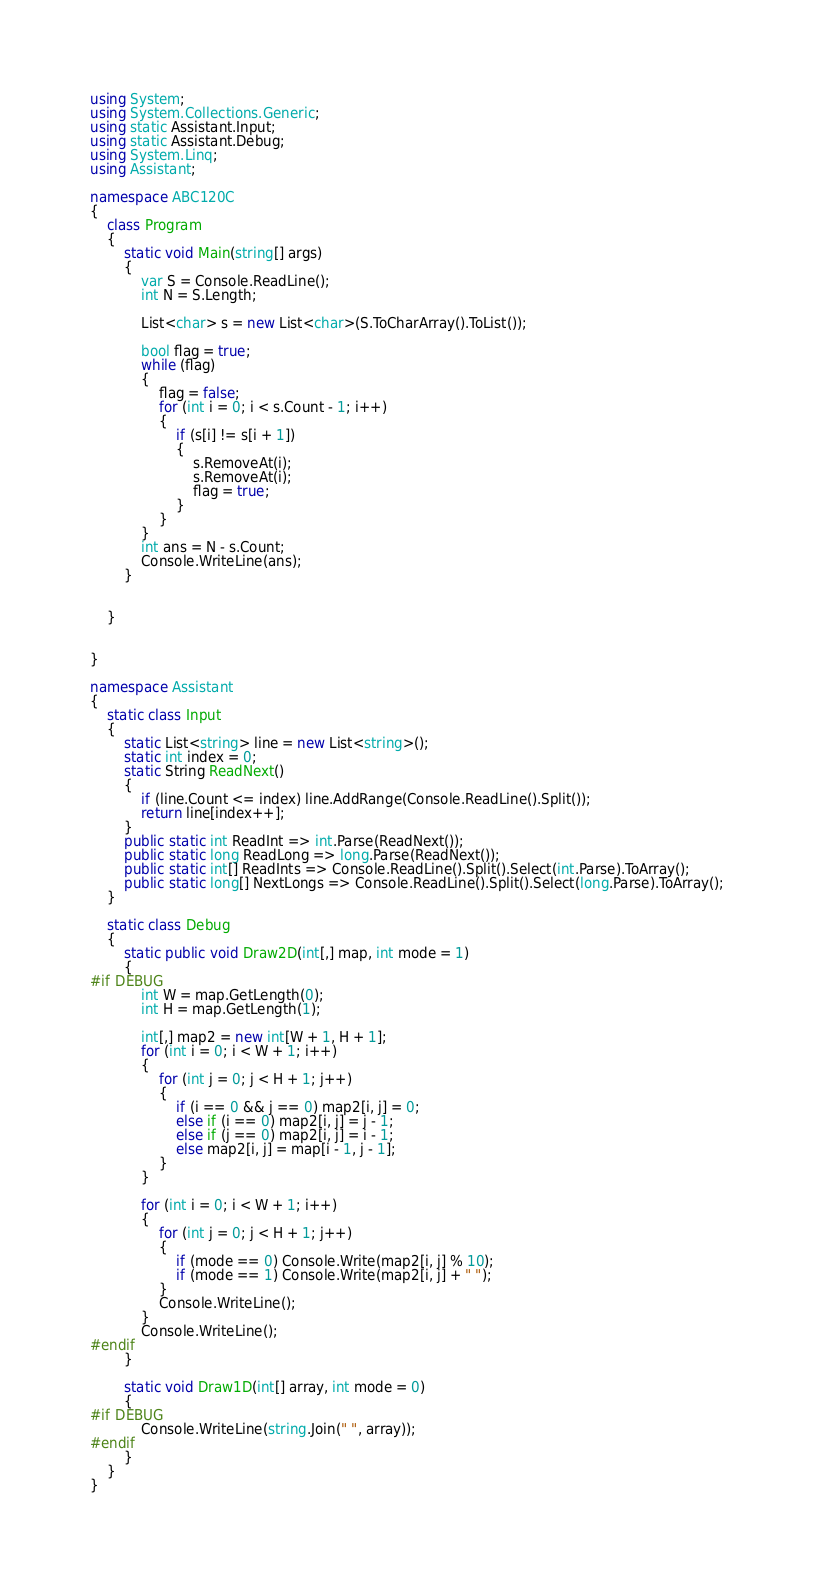<code> <loc_0><loc_0><loc_500><loc_500><_C#_>using System;
using System.Collections.Generic;
using static Assistant.Input;
using static Assistant.Debug;
using System.Linq;
using Assistant;

namespace ABC120C
{
    class Program
    {
        static void Main(string[] args)
        {
            var S = Console.ReadLine();
            int N = S.Length;

            List<char> s = new List<char>(S.ToCharArray().ToList());

            bool flag = true;
            while (flag)
            {
                flag = false;
                for (int i = 0; i < s.Count - 1; i++)
                {
                    if (s[i] != s[i + 1])
                    {
                        s.RemoveAt(i);
                        s.RemoveAt(i);
                        flag = true;
                    }
                }
            }
            int ans = N - s.Count;
            Console.WriteLine(ans);
        }


    }


}

namespace Assistant
{
    static class Input
    {
        static List<string> line = new List<string>();
        static int index = 0;
        static String ReadNext()
        {
            if (line.Count <= index) line.AddRange(Console.ReadLine().Split());
            return line[index++];
        }
        public static int ReadInt => int.Parse(ReadNext());
        public static long ReadLong => long.Parse(ReadNext());
        public static int[] ReadInts => Console.ReadLine().Split().Select(int.Parse).ToArray();
        public static long[] NextLongs => Console.ReadLine().Split().Select(long.Parse).ToArray();
    }

    static class Debug
    {
        static public void Draw2D(int[,] map, int mode = 1)
        {
#if DEBUG
            int W = map.GetLength(0);
            int H = map.GetLength(1);

            int[,] map2 = new int[W + 1, H + 1];
            for (int i = 0; i < W + 1; i++)
            {
                for (int j = 0; j < H + 1; j++)
                {
                    if (i == 0 && j == 0) map2[i, j] = 0;
                    else if (i == 0) map2[i, j] = j - 1;
                    else if (j == 0) map2[i, j] = i - 1;
                    else map2[i, j] = map[i - 1, j - 1];
                }
            }

            for (int i = 0; i < W + 1; i++)
            {
                for (int j = 0; j < H + 1; j++)
                {
                    if (mode == 0) Console.Write(map2[i, j] % 10);
                    if (mode == 1) Console.Write(map2[i, j] + " ");
                }
                Console.WriteLine();
            }
            Console.WriteLine();
#endif
        }

        static void Draw1D(int[] array, int mode = 0)
        {
#if DEBUG
            Console.WriteLine(string.Join(" ", array));
#endif
        }
    }
}
</code> 